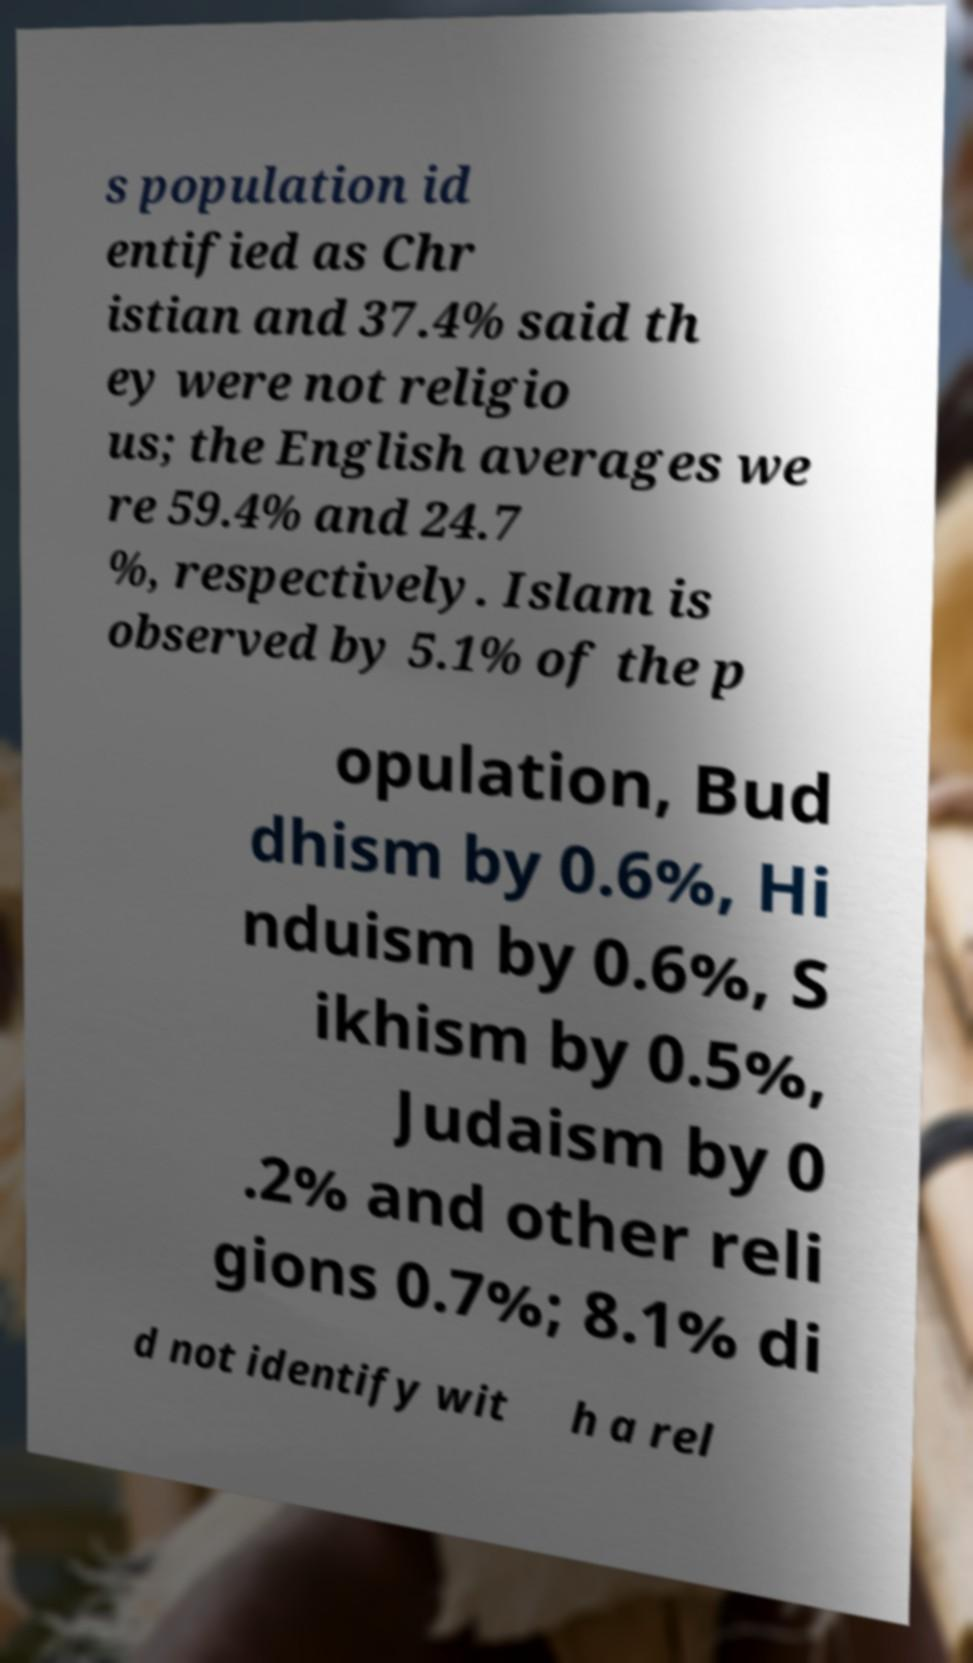Please identify and transcribe the text found in this image. s population id entified as Chr istian and 37.4% said th ey were not religio us; the English averages we re 59.4% and 24.7 %, respectively. Islam is observed by 5.1% of the p opulation, Bud dhism by 0.6%, Hi nduism by 0.6%, S ikhism by 0.5%, Judaism by 0 .2% and other reli gions 0.7%; 8.1% di d not identify wit h a rel 